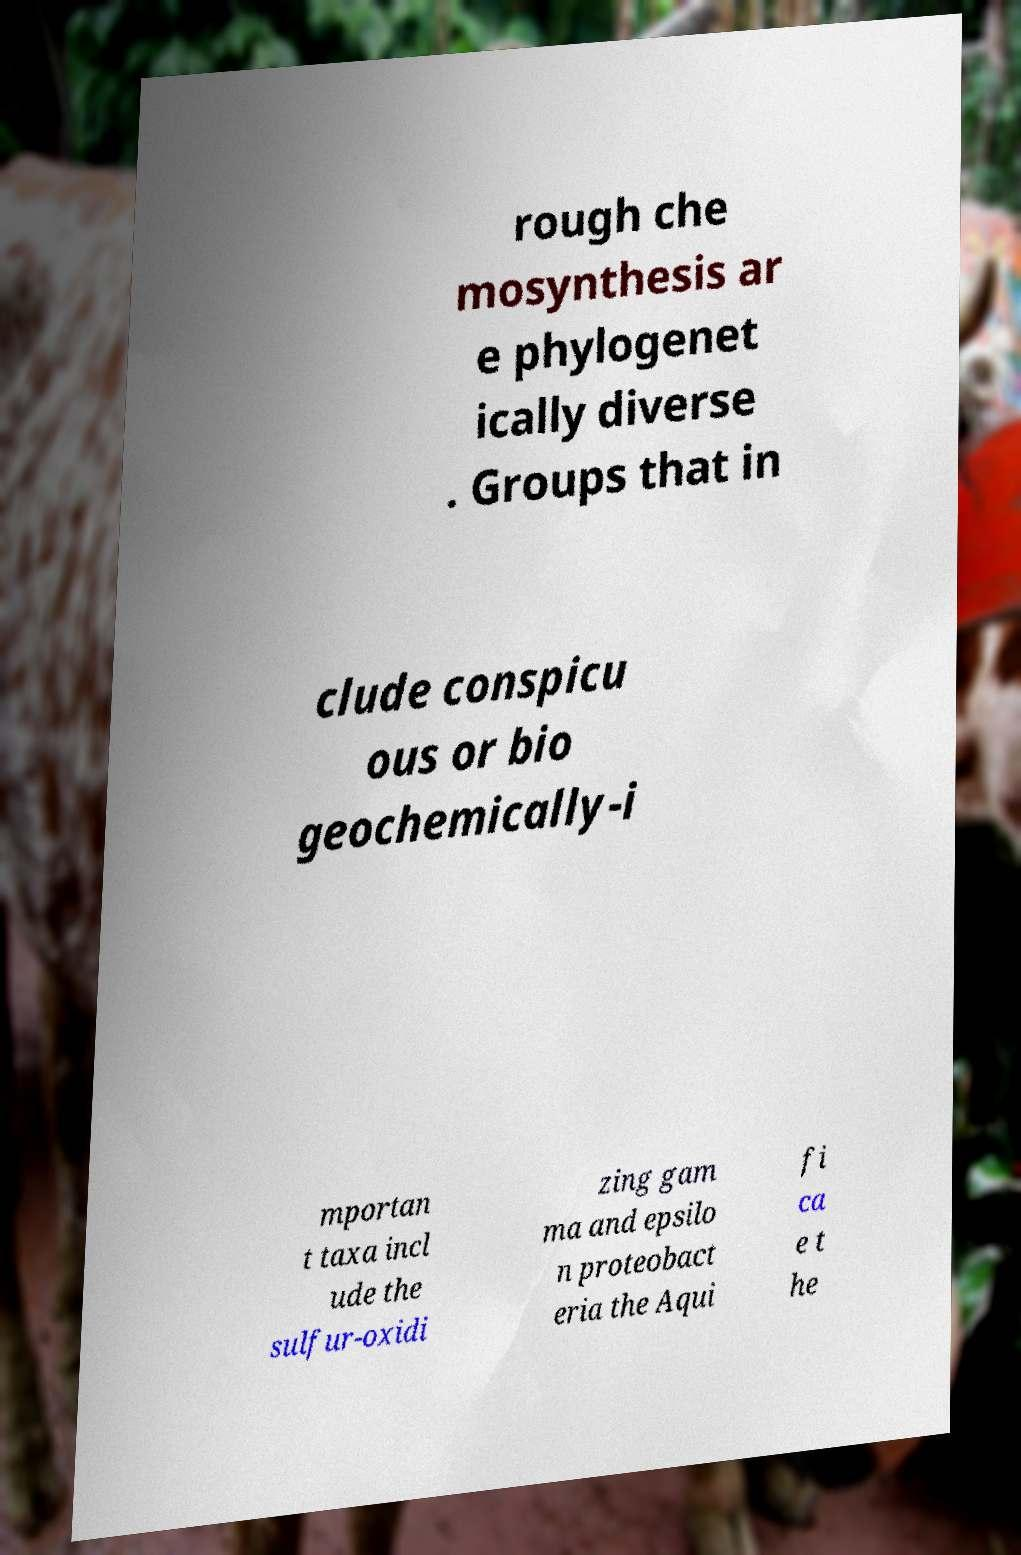Please read and relay the text visible in this image. What does it say? rough che mosynthesis ar e phylogenet ically diverse . Groups that in clude conspicu ous or bio geochemically-i mportan t taxa incl ude the sulfur-oxidi zing gam ma and epsilo n proteobact eria the Aqui fi ca e t he 